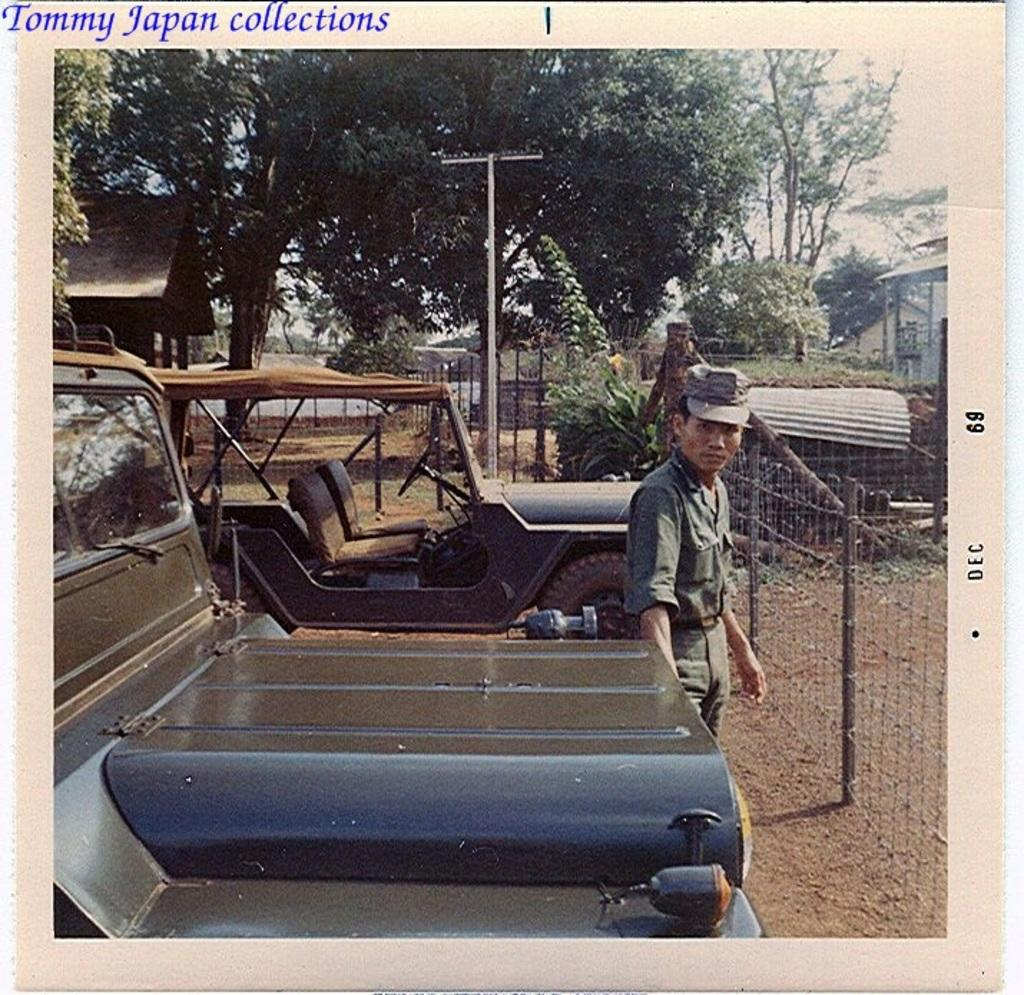How many vehicles are parked in the image? There are two vehicles parked in the image. What is the person in front of the vehicles doing? The person is standing in front of the vehicles. What can be seen in the background of the image? Trees, railings, plants, poles, and houses are visible in the background of the image. How many eggs are being used to decorate the vehicles in the image? There are no eggs present in the image, and they are not being used to decorate the vehicles. 